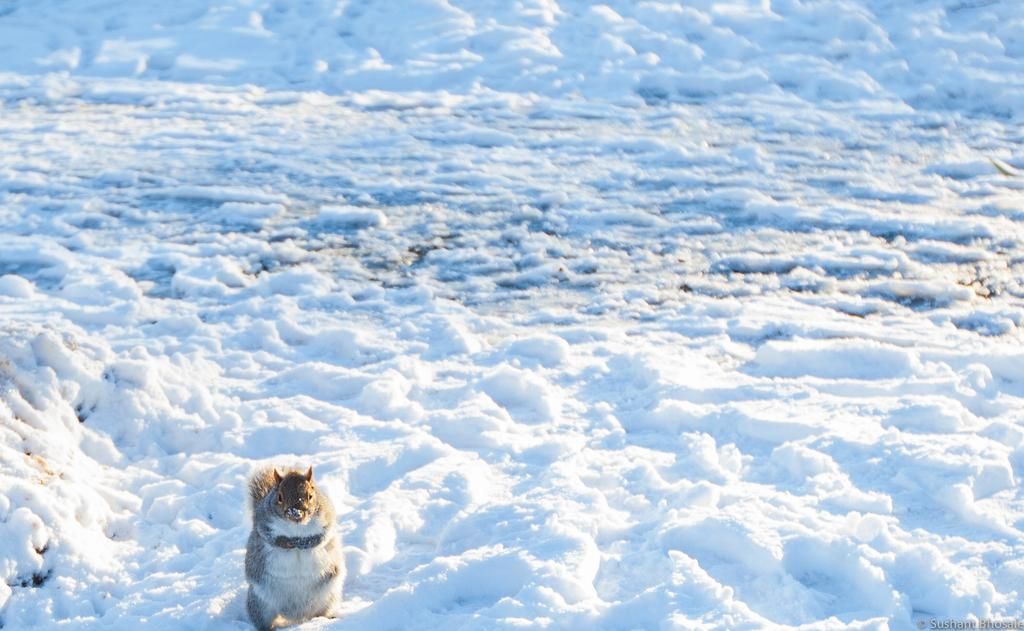What type of animal is in the image? There is a squirrel in the image. Where is the squirrel located? The squirrel is on the snow. What type of tomatoes can be seen growing in the image? There are no tomatoes present in the image; it features a squirrel on the snow. What sound does the squirrel make in the image? The image is static, so no sound can be heard or depicted. 